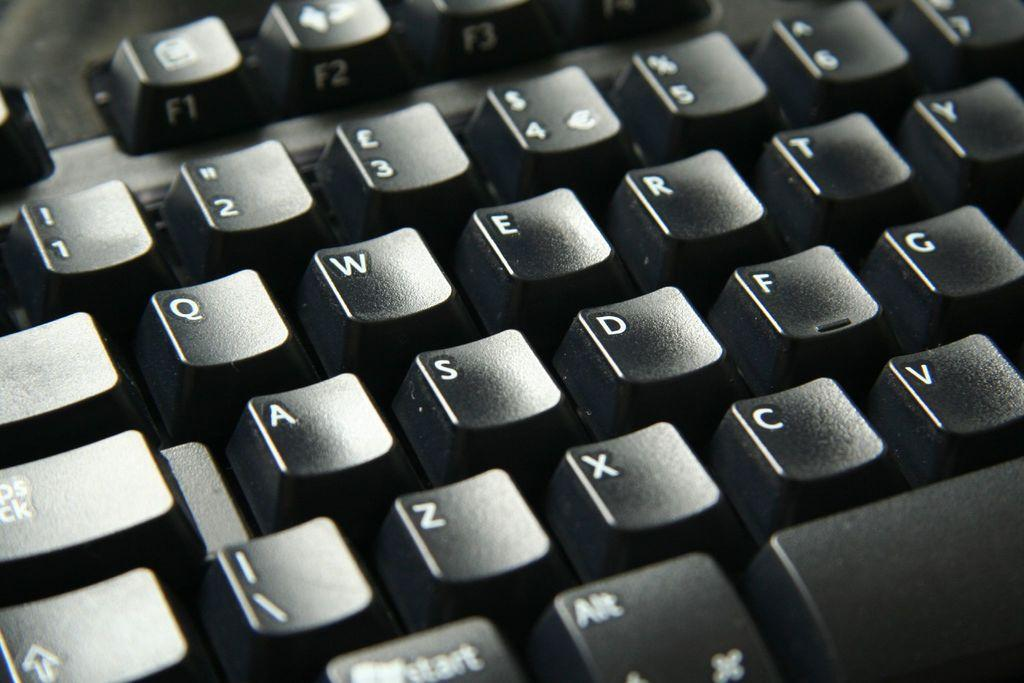<image>
Relay a brief, clear account of the picture shown. A computer keyboard where the q,w,e,r,t and y are visible. 